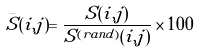Convert formula to latex. <formula><loc_0><loc_0><loc_500><loc_500>\bar { S } ( i , j ) = \frac { S ( i , j ) } { S ^ { ( r a n d ) } ( i , j ) } \times 1 0 0</formula> 